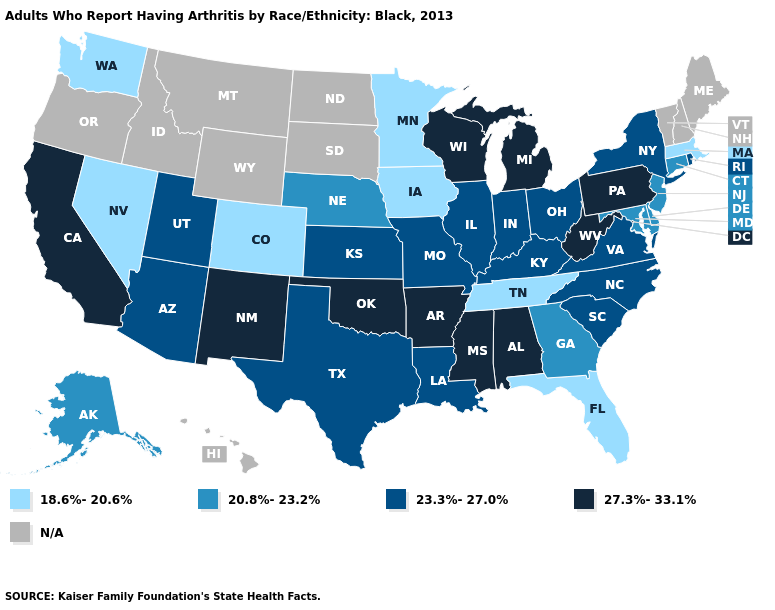What is the value of Hawaii?
Quick response, please. N/A. Does the map have missing data?
Be succinct. Yes. How many symbols are there in the legend?
Be succinct. 5. Is the legend a continuous bar?
Write a very short answer. No. Among the states that border Utah , does New Mexico have the highest value?
Short answer required. Yes. Among the states that border North Carolina , which have the lowest value?
Short answer required. Tennessee. Is the legend a continuous bar?
Be succinct. No. Which states have the lowest value in the Northeast?
Concise answer only. Massachusetts. Which states hav the highest value in the MidWest?
Short answer required. Michigan, Wisconsin. Among the states that border Indiana , which have the highest value?
Quick response, please. Michigan. Name the states that have a value in the range 27.3%-33.1%?
Write a very short answer. Alabama, Arkansas, California, Michigan, Mississippi, New Mexico, Oklahoma, Pennsylvania, West Virginia, Wisconsin. Name the states that have a value in the range N/A?
Concise answer only. Hawaii, Idaho, Maine, Montana, New Hampshire, North Dakota, Oregon, South Dakota, Vermont, Wyoming. Does Indiana have the highest value in the USA?
Concise answer only. No. Among the states that border Pennsylvania , which have the highest value?
Write a very short answer. West Virginia. 